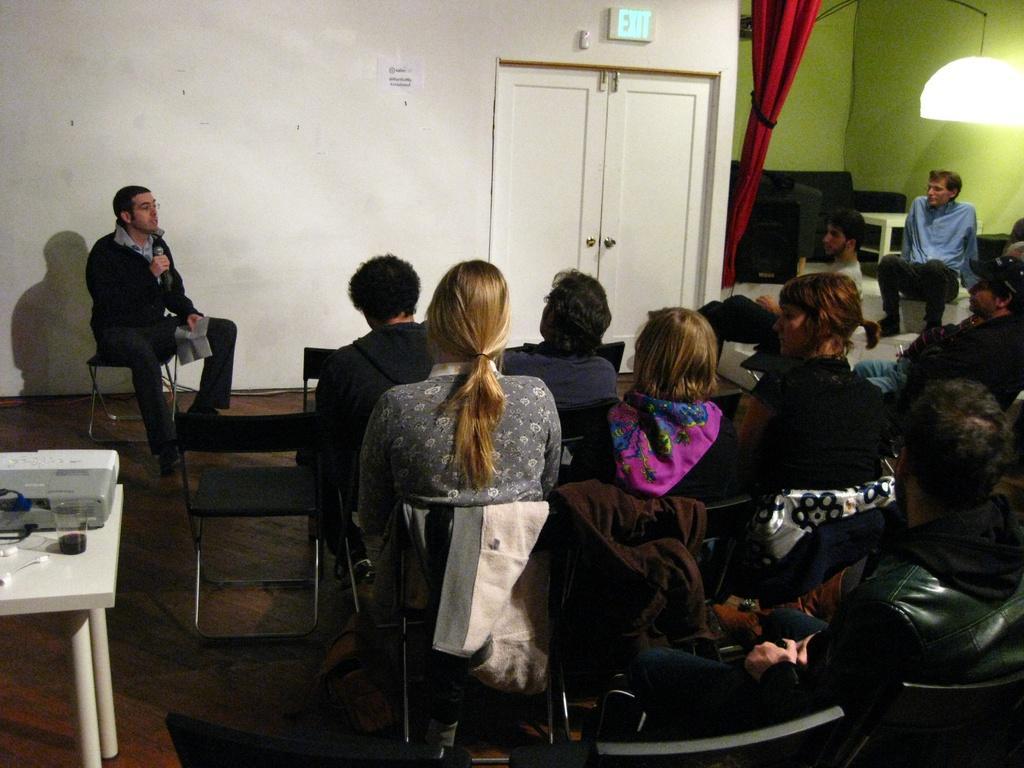Could you give a brief overview of what you see in this image? In this image there are group of people. On the table there is a glass. The man is holding a mic. 